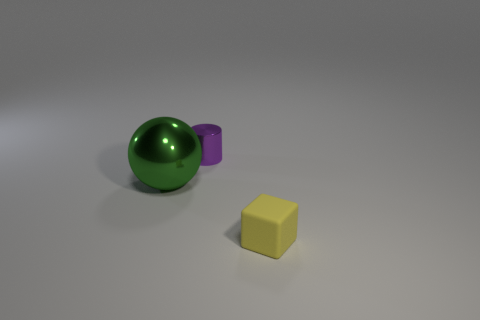Add 3 purple metal balls. How many objects exist? 6 Subtract all blocks. How many objects are left? 2 Add 1 shiny cylinders. How many shiny cylinders are left? 2 Add 2 tiny cyan rubber spheres. How many tiny cyan rubber spheres exist? 2 Subtract 0 blue spheres. How many objects are left? 3 Subtract all tiny gray cylinders. Subtract all large green shiny balls. How many objects are left? 2 